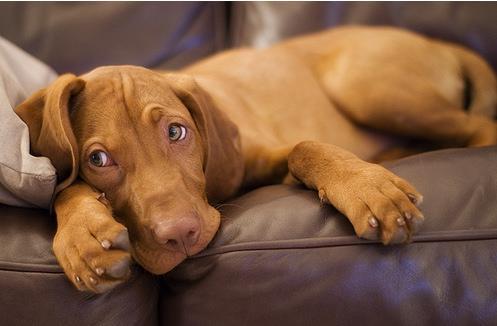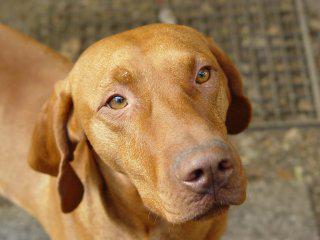The first image is the image on the left, the second image is the image on the right. Given the left and right images, does the statement "There are no more than two dogs." hold true? Answer yes or no. Yes. The first image is the image on the left, the second image is the image on the right. For the images displayed, is the sentence "An image shows exactly one dog reclining on a soft piece of furniture, with its rear to the right and its head to the left." factually correct? Answer yes or no. Yes. 